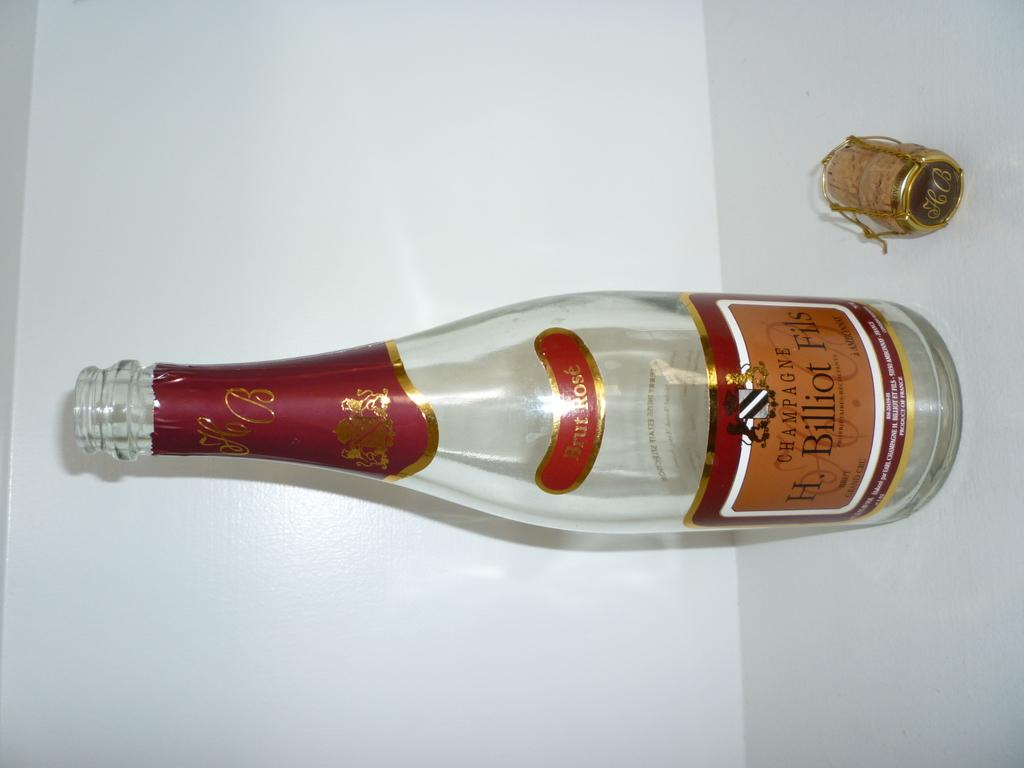<image>
Share a concise interpretation of the image provided. An empty bottle of Billiot Fils Champagne with the cork next to it.. 